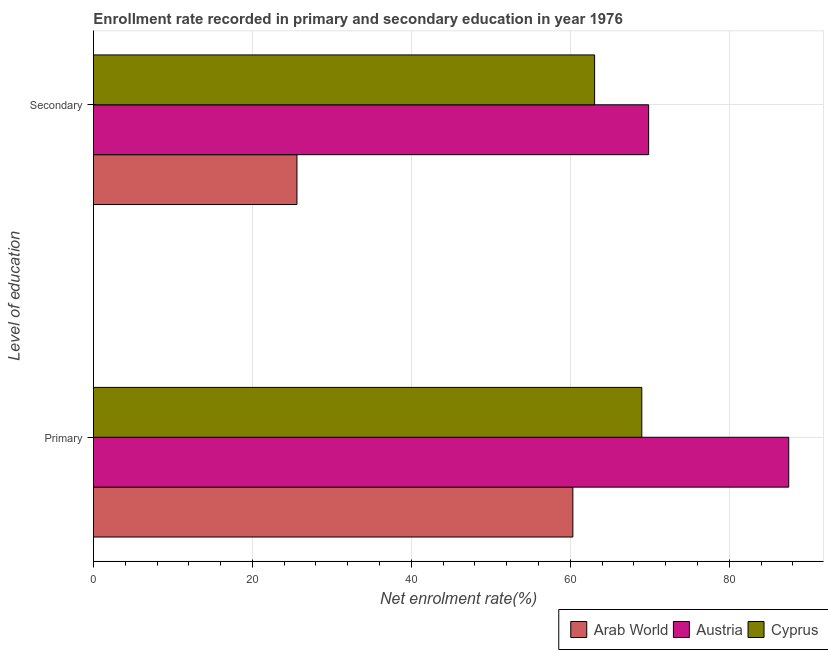How many different coloured bars are there?
Keep it short and to the point. 3. What is the label of the 2nd group of bars from the top?
Offer a terse response. Primary. What is the enrollment rate in primary education in Cyprus?
Ensure brevity in your answer.  69. Across all countries, what is the maximum enrollment rate in secondary education?
Offer a very short reply. 69.86. Across all countries, what is the minimum enrollment rate in secondary education?
Your response must be concise. 25.61. In which country was the enrollment rate in primary education minimum?
Offer a terse response. Arab World. What is the total enrollment rate in primary education in the graph?
Provide a short and direct response. 216.81. What is the difference between the enrollment rate in secondary education in Austria and that in Cyprus?
Provide a succinct answer. 6.8. What is the difference between the enrollment rate in secondary education in Arab World and the enrollment rate in primary education in Cyprus?
Your answer should be compact. -43.39. What is the average enrollment rate in secondary education per country?
Your answer should be very brief. 52.84. What is the difference between the enrollment rate in secondary education and enrollment rate in primary education in Cyprus?
Your response must be concise. -5.94. In how many countries, is the enrollment rate in secondary education greater than 16 %?
Make the answer very short. 3. What is the ratio of the enrollment rate in primary education in Arab World to that in Cyprus?
Offer a very short reply. 0.87. In how many countries, is the enrollment rate in primary education greater than the average enrollment rate in primary education taken over all countries?
Provide a succinct answer. 1. What does the 2nd bar from the top in Primary represents?
Provide a succinct answer. Austria. What does the 1st bar from the bottom in Secondary represents?
Keep it short and to the point. Arab World. How many bars are there?
Provide a short and direct response. 6. Does the graph contain grids?
Ensure brevity in your answer.  Yes. Where does the legend appear in the graph?
Your answer should be very brief. Bottom right. How many legend labels are there?
Provide a succinct answer. 3. How are the legend labels stacked?
Offer a terse response. Horizontal. What is the title of the graph?
Your answer should be compact. Enrollment rate recorded in primary and secondary education in year 1976. Does "Bermuda" appear as one of the legend labels in the graph?
Keep it short and to the point. No. What is the label or title of the X-axis?
Give a very brief answer. Net enrolment rate(%). What is the label or title of the Y-axis?
Offer a very short reply. Level of education. What is the Net enrolment rate(%) in Arab World in Primary?
Offer a very short reply. 60.32. What is the Net enrolment rate(%) of Austria in Primary?
Your response must be concise. 87.49. What is the Net enrolment rate(%) of Cyprus in Primary?
Your response must be concise. 69. What is the Net enrolment rate(%) in Arab World in Secondary?
Keep it short and to the point. 25.61. What is the Net enrolment rate(%) in Austria in Secondary?
Keep it short and to the point. 69.86. What is the Net enrolment rate(%) of Cyprus in Secondary?
Your response must be concise. 63.06. Across all Level of education, what is the maximum Net enrolment rate(%) of Arab World?
Your answer should be very brief. 60.32. Across all Level of education, what is the maximum Net enrolment rate(%) in Austria?
Make the answer very short. 87.49. Across all Level of education, what is the maximum Net enrolment rate(%) of Cyprus?
Offer a terse response. 69. Across all Level of education, what is the minimum Net enrolment rate(%) of Arab World?
Your response must be concise. 25.61. Across all Level of education, what is the minimum Net enrolment rate(%) of Austria?
Offer a very short reply. 69.86. Across all Level of education, what is the minimum Net enrolment rate(%) in Cyprus?
Ensure brevity in your answer.  63.06. What is the total Net enrolment rate(%) of Arab World in the graph?
Your response must be concise. 85.93. What is the total Net enrolment rate(%) in Austria in the graph?
Your response must be concise. 157.35. What is the total Net enrolment rate(%) of Cyprus in the graph?
Ensure brevity in your answer.  132.06. What is the difference between the Net enrolment rate(%) in Arab World in Primary and that in Secondary?
Your response must be concise. 34.72. What is the difference between the Net enrolment rate(%) in Austria in Primary and that in Secondary?
Your answer should be very brief. 17.63. What is the difference between the Net enrolment rate(%) in Cyprus in Primary and that in Secondary?
Provide a short and direct response. 5.94. What is the difference between the Net enrolment rate(%) of Arab World in Primary and the Net enrolment rate(%) of Austria in Secondary?
Your answer should be very brief. -9.54. What is the difference between the Net enrolment rate(%) in Arab World in Primary and the Net enrolment rate(%) in Cyprus in Secondary?
Provide a succinct answer. -2.74. What is the difference between the Net enrolment rate(%) of Austria in Primary and the Net enrolment rate(%) of Cyprus in Secondary?
Give a very brief answer. 24.43. What is the average Net enrolment rate(%) in Arab World per Level of education?
Provide a short and direct response. 42.96. What is the average Net enrolment rate(%) of Austria per Level of education?
Ensure brevity in your answer.  78.67. What is the average Net enrolment rate(%) in Cyprus per Level of education?
Offer a terse response. 66.03. What is the difference between the Net enrolment rate(%) of Arab World and Net enrolment rate(%) of Austria in Primary?
Your answer should be compact. -27.16. What is the difference between the Net enrolment rate(%) in Arab World and Net enrolment rate(%) in Cyprus in Primary?
Offer a very short reply. -8.67. What is the difference between the Net enrolment rate(%) in Austria and Net enrolment rate(%) in Cyprus in Primary?
Ensure brevity in your answer.  18.49. What is the difference between the Net enrolment rate(%) in Arab World and Net enrolment rate(%) in Austria in Secondary?
Provide a succinct answer. -44.25. What is the difference between the Net enrolment rate(%) in Arab World and Net enrolment rate(%) in Cyprus in Secondary?
Offer a very short reply. -37.46. What is the difference between the Net enrolment rate(%) of Austria and Net enrolment rate(%) of Cyprus in Secondary?
Your answer should be very brief. 6.8. What is the ratio of the Net enrolment rate(%) of Arab World in Primary to that in Secondary?
Provide a short and direct response. 2.36. What is the ratio of the Net enrolment rate(%) in Austria in Primary to that in Secondary?
Your answer should be very brief. 1.25. What is the ratio of the Net enrolment rate(%) in Cyprus in Primary to that in Secondary?
Give a very brief answer. 1.09. What is the difference between the highest and the second highest Net enrolment rate(%) in Arab World?
Offer a terse response. 34.72. What is the difference between the highest and the second highest Net enrolment rate(%) in Austria?
Provide a succinct answer. 17.63. What is the difference between the highest and the second highest Net enrolment rate(%) of Cyprus?
Keep it short and to the point. 5.94. What is the difference between the highest and the lowest Net enrolment rate(%) of Arab World?
Your answer should be compact. 34.72. What is the difference between the highest and the lowest Net enrolment rate(%) of Austria?
Provide a succinct answer. 17.63. What is the difference between the highest and the lowest Net enrolment rate(%) in Cyprus?
Provide a succinct answer. 5.94. 